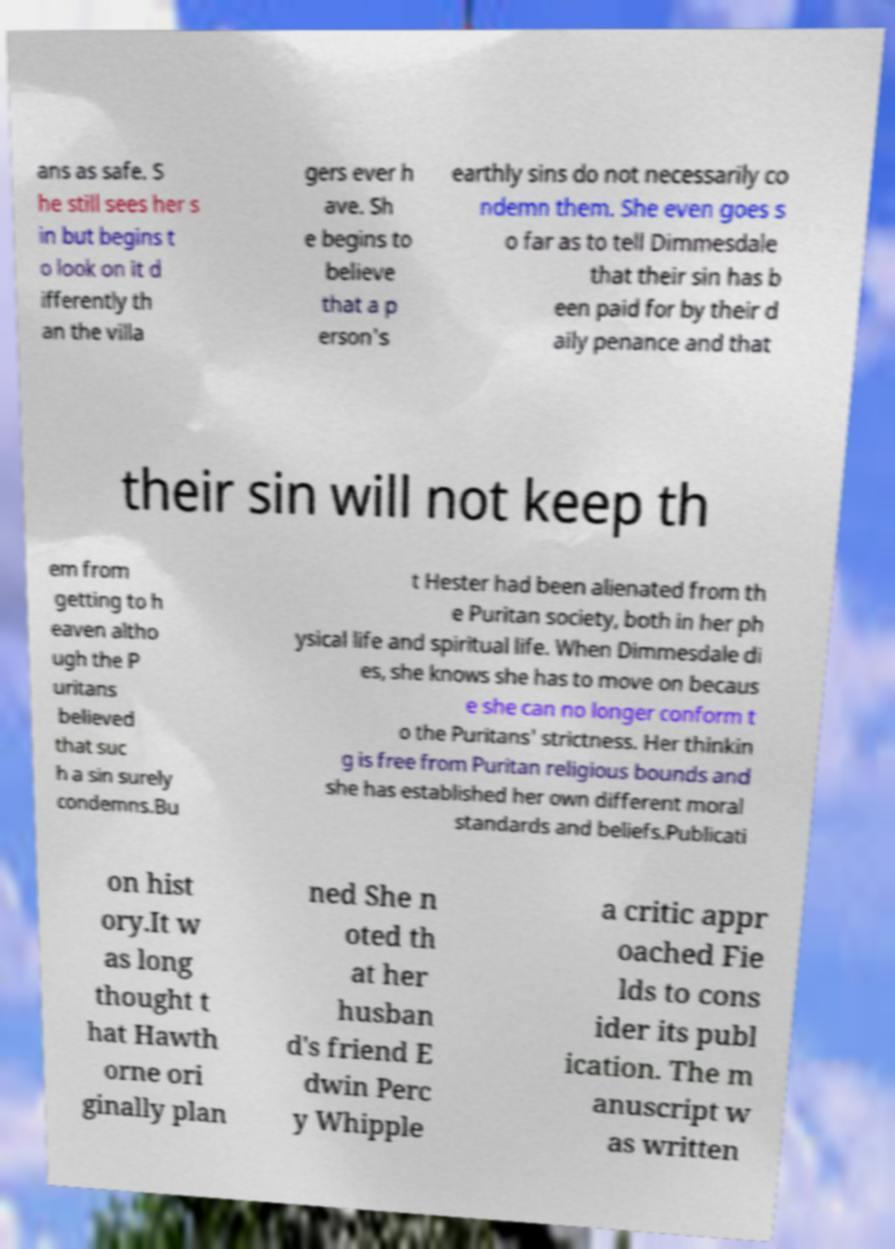Can you accurately transcribe the text from the provided image for me? ans as safe. S he still sees her s in but begins t o look on it d ifferently th an the villa gers ever h ave. Sh e begins to believe that a p erson's earthly sins do not necessarily co ndemn them. She even goes s o far as to tell Dimmesdale that their sin has b een paid for by their d aily penance and that their sin will not keep th em from getting to h eaven altho ugh the P uritans believed that suc h a sin surely condemns.Bu t Hester had been alienated from th e Puritan society, both in her ph ysical life and spiritual life. When Dimmesdale di es, she knows she has to move on becaus e she can no longer conform t o the Puritans' strictness. Her thinkin g is free from Puritan religious bounds and she has established her own different moral standards and beliefs.Publicati on hist ory.It w as long thought t hat Hawth orne ori ginally plan ned She n oted th at her husban d's friend E dwin Perc y Whipple a critic appr oached Fie lds to cons ider its publ ication. The m anuscript w as written 